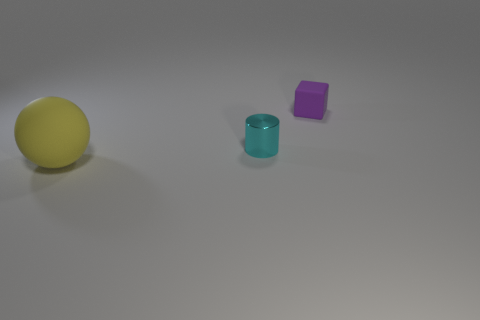What is the position of the yellow ball in relation to the other objects? The yellow ball is positioned to the far left side of the frame, with the cyan cylinder placed towards the center but slightly to the right, and the purple cube is even further to the right of the cylinder. If we look at the positioning from a different perspective, taking the cylinder as the central reference point, how would you describe it? With the cyan cylinder as the central anchor point, the yellow ball is to the left and the purple cube is to the right. If you imagine standing directly in front of the cylinder, the ball would be at your left hand, and the cube at your right. 